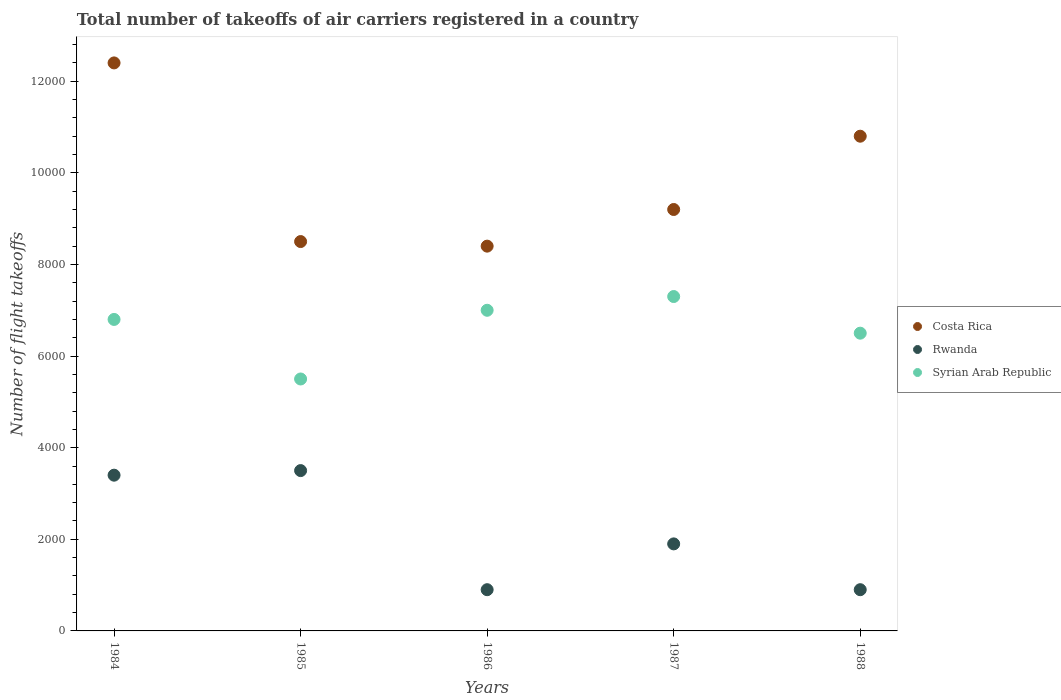Is the number of dotlines equal to the number of legend labels?
Make the answer very short. Yes. What is the total number of flight takeoffs in Costa Rica in 1985?
Offer a very short reply. 8500. Across all years, what is the maximum total number of flight takeoffs in Costa Rica?
Provide a short and direct response. 1.24e+04. Across all years, what is the minimum total number of flight takeoffs in Costa Rica?
Give a very brief answer. 8400. In which year was the total number of flight takeoffs in Rwanda maximum?
Your response must be concise. 1985. What is the total total number of flight takeoffs in Syrian Arab Republic in the graph?
Provide a succinct answer. 3.31e+04. What is the difference between the total number of flight takeoffs in Costa Rica in 1986 and that in 1987?
Make the answer very short. -800. What is the difference between the total number of flight takeoffs in Syrian Arab Republic in 1985 and the total number of flight takeoffs in Rwanda in 1987?
Ensure brevity in your answer.  3600. What is the average total number of flight takeoffs in Rwanda per year?
Give a very brief answer. 2120. In the year 1986, what is the difference between the total number of flight takeoffs in Syrian Arab Republic and total number of flight takeoffs in Costa Rica?
Give a very brief answer. -1400. In how many years, is the total number of flight takeoffs in Rwanda greater than 3600?
Provide a short and direct response. 0. What is the ratio of the total number of flight takeoffs in Costa Rica in 1985 to that in 1986?
Offer a very short reply. 1.01. What is the difference between the highest and the lowest total number of flight takeoffs in Costa Rica?
Keep it short and to the point. 4000. In how many years, is the total number of flight takeoffs in Costa Rica greater than the average total number of flight takeoffs in Costa Rica taken over all years?
Offer a terse response. 2. Is the sum of the total number of flight takeoffs in Costa Rica in 1985 and 1987 greater than the maximum total number of flight takeoffs in Rwanda across all years?
Ensure brevity in your answer.  Yes. Is it the case that in every year, the sum of the total number of flight takeoffs in Rwanda and total number of flight takeoffs in Syrian Arab Republic  is greater than the total number of flight takeoffs in Costa Rica?
Provide a short and direct response. No. Does the graph contain any zero values?
Your answer should be compact. No. Where does the legend appear in the graph?
Offer a very short reply. Center right. How are the legend labels stacked?
Give a very brief answer. Vertical. What is the title of the graph?
Make the answer very short. Total number of takeoffs of air carriers registered in a country. Does "Iraq" appear as one of the legend labels in the graph?
Provide a short and direct response. No. What is the label or title of the Y-axis?
Provide a succinct answer. Number of flight takeoffs. What is the Number of flight takeoffs of Costa Rica in 1984?
Ensure brevity in your answer.  1.24e+04. What is the Number of flight takeoffs in Rwanda in 1984?
Give a very brief answer. 3400. What is the Number of flight takeoffs in Syrian Arab Republic in 1984?
Provide a succinct answer. 6800. What is the Number of flight takeoffs in Costa Rica in 1985?
Your response must be concise. 8500. What is the Number of flight takeoffs of Rwanda in 1985?
Give a very brief answer. 3500. What is the Number of flight takeoffs of Syrian Arab Republic in 1985?
Keep it short and to the point. 5500. What is the Number of flight takeoffs of Costa Rica in 1986?
Your response must be concise. 8400. What is the Number of flight takeoffs of Rwanda in 1986?
Give a very brief answer. 900. What is the Number of flight takeoffs of Syrian Arab Republic in 1986?
Your answer should be compact. 7000. What is the Number of flight takeoffs of Costa Rica in 1987?
Your answer should be compact. 9200. What is the Number of flight takeoffs in Rwanda in 1987?
Your answer should be very brief. 1900. What is the Number of flight takeoffs of Syrian Arab Republic in 1987?
Provide a succinct answer. 7300. What is the Number of flight takeoffs of Costa Rica in 1988?
Keep it short and to the point. 1.08e+04. What is the Number of flight takeoffs in Rwanda in 1988?
Your response must be concise. 900. What is the Number of flight takeoffs of Syrian Arab Republic in 1988?
Give a very brief answer. 6500. Across all years, what is the maximum Number of flight takeoffs of Costa Rica?
Provide a succinct answer. 1.24e+04. Across all years, what is the maximum Number of flight takeoffs in Rwanda?
Give a very brief answer. 3500. Across all years, what is the maximum Number of flight takeoffs of Syrian Arab Republic?
Ensure brevity in your answer.  7300. Across all years, what is the minimum Number of flight takeoffs in Costa Rica?
Provide a short and direct response. 8400. Across all years, what is the minimum Number of flight takeoffs in Rwanda?
Keep it short and to the point. 900. Across all years, what is the minimum Number of flight takeoffs in Syrian Arab Republic?
Make the answer very short. 5500. What is the total Number of flight takeoffs of Costa Rica in the graph?
Provide a short and direct response. 4.93e+04. What is the total Number of flight takeoffs in Rwanda in the graph?
Your response must be concise. 1.06e+04. What is the total Number of flight takeoffs in Syrian Arab Republic in the graph?
Give a very brief answer. 3.31e+04. What is the difference between the Number of flight takeoffs in Costa Rica in 1984 and that in 1985?
Your response must be concise. 3900. What is the difference between the Number of flight takeoffs in Rwanda in 1984 and that in 1985?
Your answer should be compact. -100. What is the difference between the Number of flight takeoffs in Syrian Arab Republic in 1984 and that in 1985?
Keep it short and to the point. 1300. What is the difference between the Number of flight takeoffs in Costa Rica in 1984 and that in 1986?
Your answer should be very brief. 4000. What is the difference between the Number of flight takeoffs of Rwanda in 1984 and that in 1986?
Your answer should be very brief. 2500. What is the difference between the Number of flight takeoffs of Syrian Arab Republic in 1984 and that in 1986?
Provide a short and direct response. -200. What is the difference between the Number of flight takeoffs in Costa Rica in 1984 and that in 1987?
Your answer should be very brief. 3200. What is the difference between the Number of flight takeoffs of Rwanda in 1984 and that in 1987?
Your answer should be compact. 1500. What is the difference between the Number of flight takeoffs of Syrian Arab Republic in 1984 and that in 1987?
Make the answer very short. -500. What is the difference between the Number of flight takeoffs in Costa Rica in 1984 and that in 1988?
Keep it short and to the point. 1600. What is the difference between the Number of flight takeoffs in Rwanda in 1984 and that in 1988?
Your answer should be very brief. 2500. What is the difference between the Number of flight takeoffs in Syrian Arab Republic in 1984 and that in 1988?
Make the answer very short. 300. What is the difference between the Number of flight takeoffs of Costa Rica in 1985 and that in 1986?
Your answer should be very brief. 100. What is the difference between the Number of flight takeoffs of Rwanda in 1985 and that in 1986?
Provide a succinct answer. 2600. What is the difference between the Number of flight takeoffs of Syrian Arab Republic in 1985 and that in 1986?
Keep it short and to the point. -1500. What is the difference between the Number of flight takeoffs in Costa Rica in 1985 and that in 1987?
Provide a succinct answer. -700. What is the difference between the Number of flight takeoffs in Rwanda in 1985 and that in 1987?
Your answer should be very brief. 1600. What is the difference between the Number of flight takeoffs of Syrian Arab Republic in 1985 and that in 1987?
Give a very brief answer. -1800. What is the difference between the Number of flight takeoffs in Costa Rica in 1985 and that in 1988?
Give a very brief answer. -2300. What is the difference between the Number of flight takeoffs of Rwanda in 1985 and that in 1988?
Your answer should be very brief. 2600. What is the difference between the Number of flight takeoffs of Syrian Arab Republic in 1985 and that in 1988?
Offer a very short reply. -1000. What is the difference between the Number of flight takeoffs of Costa Rica in 1986 and that in 1987?
Your response must be concise. -800. What is the difference between the Number of flight takeoffs in Rwanda in 1986 and that in 1987?
Your response must be concise. -1000. What is the difference between the Number of flight takeoffs in Syrian Arab Republic in 1986 and that in 1987?
Your answer should be compact. -300. What is the difference between the Number of flight takeoffs of Costa Rica in 1986 and that in 1988?
Ensure brevity in your answer.  -2400. What is the difference between the Number of flight takeoffs in Rwanda in 1986 and that in 1988?
Your response must be concise. 0. What is the difference between the Number of flight takeoffs of Syrian Arab Republic in 1986 and that in 1988?
Keep it short and to the point. 500. What is the difference between the Number of flight takeoffs of Costa Rica in 1987 and that in 1988?
Keep it short and to the point. -1600. What is the difference between the Number of flight takeoffs in Syrian Arab Republic in 1987 and that in 1988?
Your response must be concise. 800. What is the difference between the Number of flight takeoffs of Costa Rica in 1984 and the Number of flight takeoffs of Rwanda in 1985?
Your answer should be very brief. 8900. What is the difference between the Number of flight takeoffs in Costa Rica in 1984 and the Number of flight takeoffs in Syrian Arab Republic in 1985?
Ensure brevity in your answer.  6900. What is the difference between the Number of flight takeoffs of Rwanda in 1984 and the Number of flight takeoffs of Syrian Arab Republic in 1985?
Offer a terse response. -2100. What is the difference between the Number of flight takeoffs of Costa Rica in 1984 and the Number of flight takeoffs of Rwanda in 1986?
Provide a short and direct response. 1.15e+04. What is the difference between the Number of flight takeoffs in Costa Rica in 1984 and the Number of flight takeoffs in Syrian Arab Republic in 1986?
Make the answer very short. 5400. What is the difference between the Number of flight takeoffs of Rwanda in 1984 and the Number of flight takeoffs of Syrian Arab Republic in 1986?
Provide a succinct answer. -3600. What is the difference between the Number of flight takeoffs in Costa Rica in 1984 and the Number of flight takeoffs in Rwanda in 1987?
Provide a succinct answer. 1.05e+04. What is the difference between the Number of flight takeoffs of Costa Rica in 1984 and the Number of flight takeoffs of Syrian Arab Republic in 1987?
Offer a very short reply. 5100. What is the difference between the Number of flight takeoffs of Rwanda in 1984 and the Number of flight takeoffs of Syrian Arab Republic in 1987?
Keep it short and to the point. -3900. What is the difference between the Number of flight takeoffs in Costa Rica in 1984 and the Number of flight takeoffs in Rwanda in 1988?
Provide a succinct answer. 1.15e+04. What is the difference between the Number of flight takeoffs in Costa Rica in 1984 and the Number of flight takeoffs in Syrian Arab Republic in 1988?
Your answer should be compact. 5900. What is the difference between the Number of flight takeoffs in Rwanda in 1984 and the Number of flight takeoffs in Syrian Arab Republic in 1988?
Give a very brief answer. -3100. What is the difference between the Number of flight takeoffs of Costa Rica in 1985 and the Number of flight takeoffs of Rwanda in 1986?
Your answer should be very brief. 7600. What is the difference between the Number of flight takeoffs of Costa Rica in 1985 and the Number of flight takeoffs of Syrian Arab Republic in 1986?
Your response must be concise. 1500. What is the difference between the Number of flight takeoffs of Rwanda in 1985 and the Number of flight takeoffs of Syrian Arab Republic in 1986?
Make the answer very short. -3500. What is the difference between the Number of flight takeoffs in Costa Rica in 1985 and the Number of flight takeoffs in Rwanda in 1987?
Provide a short and direct response. 6600. What is the difference between the Number of flight takeoffs of Costa Rica in 1985 and the Number of flight takeoffs of Syrian Arab Republic in 1987?
Provide a succinct answer. 1200. What is the difference between the Number of flight takeoffs in Rwanda in 1985 and the Number of flight takeoffs in Syrian Arab Republic in 1987?
Offer a terse response. -3800. What is the difference between the Number of flight takeoffs of Costa Rica in 1985 and the Number of flight takeoffs of Rwanda in 1988?
Provide a short and direct response. 7600. What is the difference between the Number of flight takeoffs of Costa Rica in 1985 and the Number of flight takeoffs of Syrian Arab Republic in 1988?
Make the answer very short. 2000. What is the difference between the Number of flight takeoffs in Rwanda in 1985 and the Number of flight takeoffs in Syrian Arab Republic in 1988?
Make the answer very short. -3000. What is the difference between the Number of flight takeoffs of Costa Rica in 1986 and the Number of flight takeoffs of Rwanda in 1987?
Keep it short and to the point. 6500. What is the difference between the Number of flight takeoffs in Costa Rica in 1986 and the Number of flight takeoffs in Syrian Arab Republic in 1987?
Make the answer very short. 1100. What is the difference between the Number of flight takeoffs in Rwanda in 1986 and the Number of flight takeoffs in Syrian Arab Republic in 1987?
Your response must be concise. -6400. What is the difference between the Number of flight takeoffs in Costa Rica in 1986 and the Number of flight takeoffs in Rwanda in 1988?
Provide a short and direct response. 7500. What is the difference between the Number of flight takeoffs of Costa Rica in 1986 and the Number of flight takeoffs of Syrian Arab Republic in 1988?
Your answer should be compact. 1900. What is the difference between the Number of flight takeoffs of Rwanda in 1986 and the Number of flight takeoffs of Syrian Arab Republic in 1988?
Offer a very short reply. -5600. What is the difference between the Number of flight takeoffs of Costa Rica in 1987 and the Number of flight takeoffs of Rwanda in 1988?
Make the answer very short. 8300. What is the difference between the Number of flight takeoffs in Costa Rica in 1987 and the Number of flight takeoffs in Syrian Arab Republic in 1988?
Ensure brevity in your answer.  2700. What is the difference between the Number of flight takeoffs in Rwanda in 1987 and the Number of flight takeoffs in Syrian Arab Republic in 1988?
Your answer should be compact. -4600. What is the average Number of flight takeoffs of Costa Rica per year?
Offer a terse response. 9860. What is the average Number of flight takeoffs in Rwanda per year?
Give a very brief answer. 2120. What is the average Number of flight takeoffs in Syrian Arab Republic per year?
Keep it short and to the point. 6620. In the year 1984, what is the difference between the Number of flight takeoffs in Costa Rica and Number of flight takeoffs in Rwanda?
Provide a succinct answer. 9000. In the year 1984, what is the difference between the Number of flight takeoffs in Costa Rica and Number of flight takeoffs in Syrian Arab Republic?
Your answer should be very brief. 5600. In the year 1984, what is the difference between the Number of flight takeoffs of Rwanda and Number of flight takeoffs of Syrian Arab Republic?
Provide a short and direct response. -3400. In the year 1985, what is the difference between the Number of flight takeoffs of Costa Rica and Number of flight takeoffs of Rwanda?
Provide a succinct answer. 5000. In the year 1985, what is the difference between the Number of flight takeoffs of Costa Rica and Number of flight takeoffs of Syrian Arab Republic?
Your answer should be very brief. 3000. In the year 1985, what is the difference between the Number of flight takeoffs of Rwanda and Number of flight takeoffs of Syrian Arab Republic?
Provide a short and direct response. -2000. In the year 1986, what is the difference between the Number of flight takeoffs in Costa Rica and Number of flight takeoffs in Rwanda?
Your answer should be very brief. 7500. In the year 1986, what is the difference between the Number of flight takeoffs in Costa Rica and Number of flight takeoffs in Syrian Arab Republic?
Provide a succinct answer. 1400. In the year 1986, what is the difference between the Number of flight takeoffs of Rwanda and Number of flight takeoffs of Syrian Arab Republic?
Provide a succinct answer. -6100. In the year 1987, what is the difference between the Number of flight takeoffs of Costa Rica and Number of flight takeoffs of Rwanda?
Your response must be concise. 7300. In the year 1987, what is the difference between the Number of flight takeoffs of Costa Rica and Number of flight takeoffs of Syrian Arab Republic?
Provide a short and direct response. 1900. In the year 1987, what is the difference between the Number of flight takeoffs in Rwanda and Number of flight takeoffs in Syrian Arab Republic?
Provide a short and direct response. -5400. In the year 1988, what is the difference between the Number of flight takeoffs of Costa Rica and Number of flight takeoffs of Rwanda?
Offer a terse response. 9900. In the year 1988, what is the difference between the Number of flight takeoffs in Costa Rica and Number of flight takeoffs in Syrian Arab Republic?
Your answer should be compact. 4300. In the year 1988, what is the difference between the Number of flight takeoffs of Rwanda and Number of flight takeoffs of Syrian Arab Republic?
Your answer should be compact. -5600. What is the ratio of the Number of flight takeoffs of Costa Rica in 1984 to that in 1985?
Provide a short and direct response. 1.46. What is the ratio of the Number of flight takeoffs in Rwanda in 1984 to that in 1985?
Your response must be concise. 0.97. What is the ratio of the Number of flight takeoffs in Syrian Arab Republic in 1984 to that in 1985?
Give a very brief answer. 1.24. What is the ratio of the Number of flight takeoffs of Costa Rica in 1984 to that in 1986?
Provide a succinct answer. 1.48. What is the ratio of the Number of flight takeoffs in Rwanda in 1984 to that in 1986?
Your answer should be very brief. 3.78. What is the ratio of the Number of flight takeoffs in Syrian Arab Republic in 1984 to that in 1986?
Provide a succinct answer. 0.97. What is the ratio of the Number of flight takeoffs of Costa Rica in 1984 to that in 1987?
Offer a very short reply. 1.35. What is the ratio of the Number of flight takeoffs in Rwanda in 1984 to that in 1987?
Keep it short and to the point. 1.79. What is the ratio of the Number of flight takeoffs in Syrian Arab Republic in 1984 to that in 1987?
Offer a very short reply. 0.93. What is the ratio of the Number of flight takeoffs of Costa Rica in 1984 to that in 1988?
Your answer should be compact. 1.15. What is the ratio of the Number of flight takeoffs of Rwanda in 1984 to that in 1988?
Your response must be concise. 3.78. What is the ratio of the Number of flight takeoffs of Syrian Arab Republic in 1984 to that in 1988?
Keep it short and to the point. 1.05. What is the ratio of the Number of flight takeoffs in Costa Rica in 1985 to that in 1986?
Make the answer very short. 1.01. What is the ratio of the Number of flight takeoffs of Rwanda in 1985 to that in 1986?
Provide a short and direct response. 3.89. What is the ratio of the Number of flight takeoffs in Syrian Arab Republic in 1985 to that in 1986?
Offer a terse response. 0.79. What is the ratio of the Number of flight takeoffs of Costa Rica in 1985 to that in 1987?
Your answer should be compact. 0.92. What is the ratio of the Number of flight takeoffs of Rwanda in 1985 to that in 1987?
Provide a short and direct response. 1.84. What is the ratio of the Number of flight takeoffs in Syrian Arab Republic in 1985 to that in 1987?
Provide a succinct answer. 0.75. What is the ratio of the Number of flight takeoffs in Costa Rica in 1985 to that in 1988?
Your answer should be very brief. 0.79. What is the ratio of the Number of flight takeoffs in Rwanda in 1985 to that in 1988?
Provide a succinct answer. 3.89. What is the ratio of the Number of flight takeoffs of Syrian Arab Republic in 1985 to that in 1988?
Offer a very short reply. 0.85. What is the ratio of the Number of flight takeoffs of Rwanda in 1986 to that in 1987?
Give a very brief answer. 0.47. What is the ratio of the Number of flight takeoffs of Syrian Arab Republic in 1986 to that in 1987?
Your answer should be very brief. 0.96. What is the ratio of the Number of flight takeoffs of Rwanda in 1986 to that in 1988?
Provide a short and direct response. 1. What is the ratio of the Number of flight takeoffs of Costa Rica in 1987 to that in 1988?
Your answer should be compact. 0.85. What is the ratio of the Number of flight takeoffs in Rwanda in 1987 to that in 1988?
Offer a terse response. 2.11. What is the ratio of the Number of flight takeoffs of Syrian Arab Republic in 1987 to that in 1988?
Your response must be concise. 1.12. What is the difference between the highest and the second highest Number of flight takeoffs in Costa Rica?
Keep it short and to the point. 1600. What is the difference between the highest and the second highest Number of flight takeoffs in Syrian Arab Republic?
Offer a terse response. 300. What is the difference between the highest and the lowest Number of flight takeoffs in Costa Rica?
Offer a terse response. 4000. What is the difference between the highest and the lowest Number of flight takeoffs of Rwanda?
Your answer should be compact. 2600. What is the difference between the highest and the lowest Number of flight takeoffs of Syrian Arab Republic?
Offer a very short reply. 1800. 